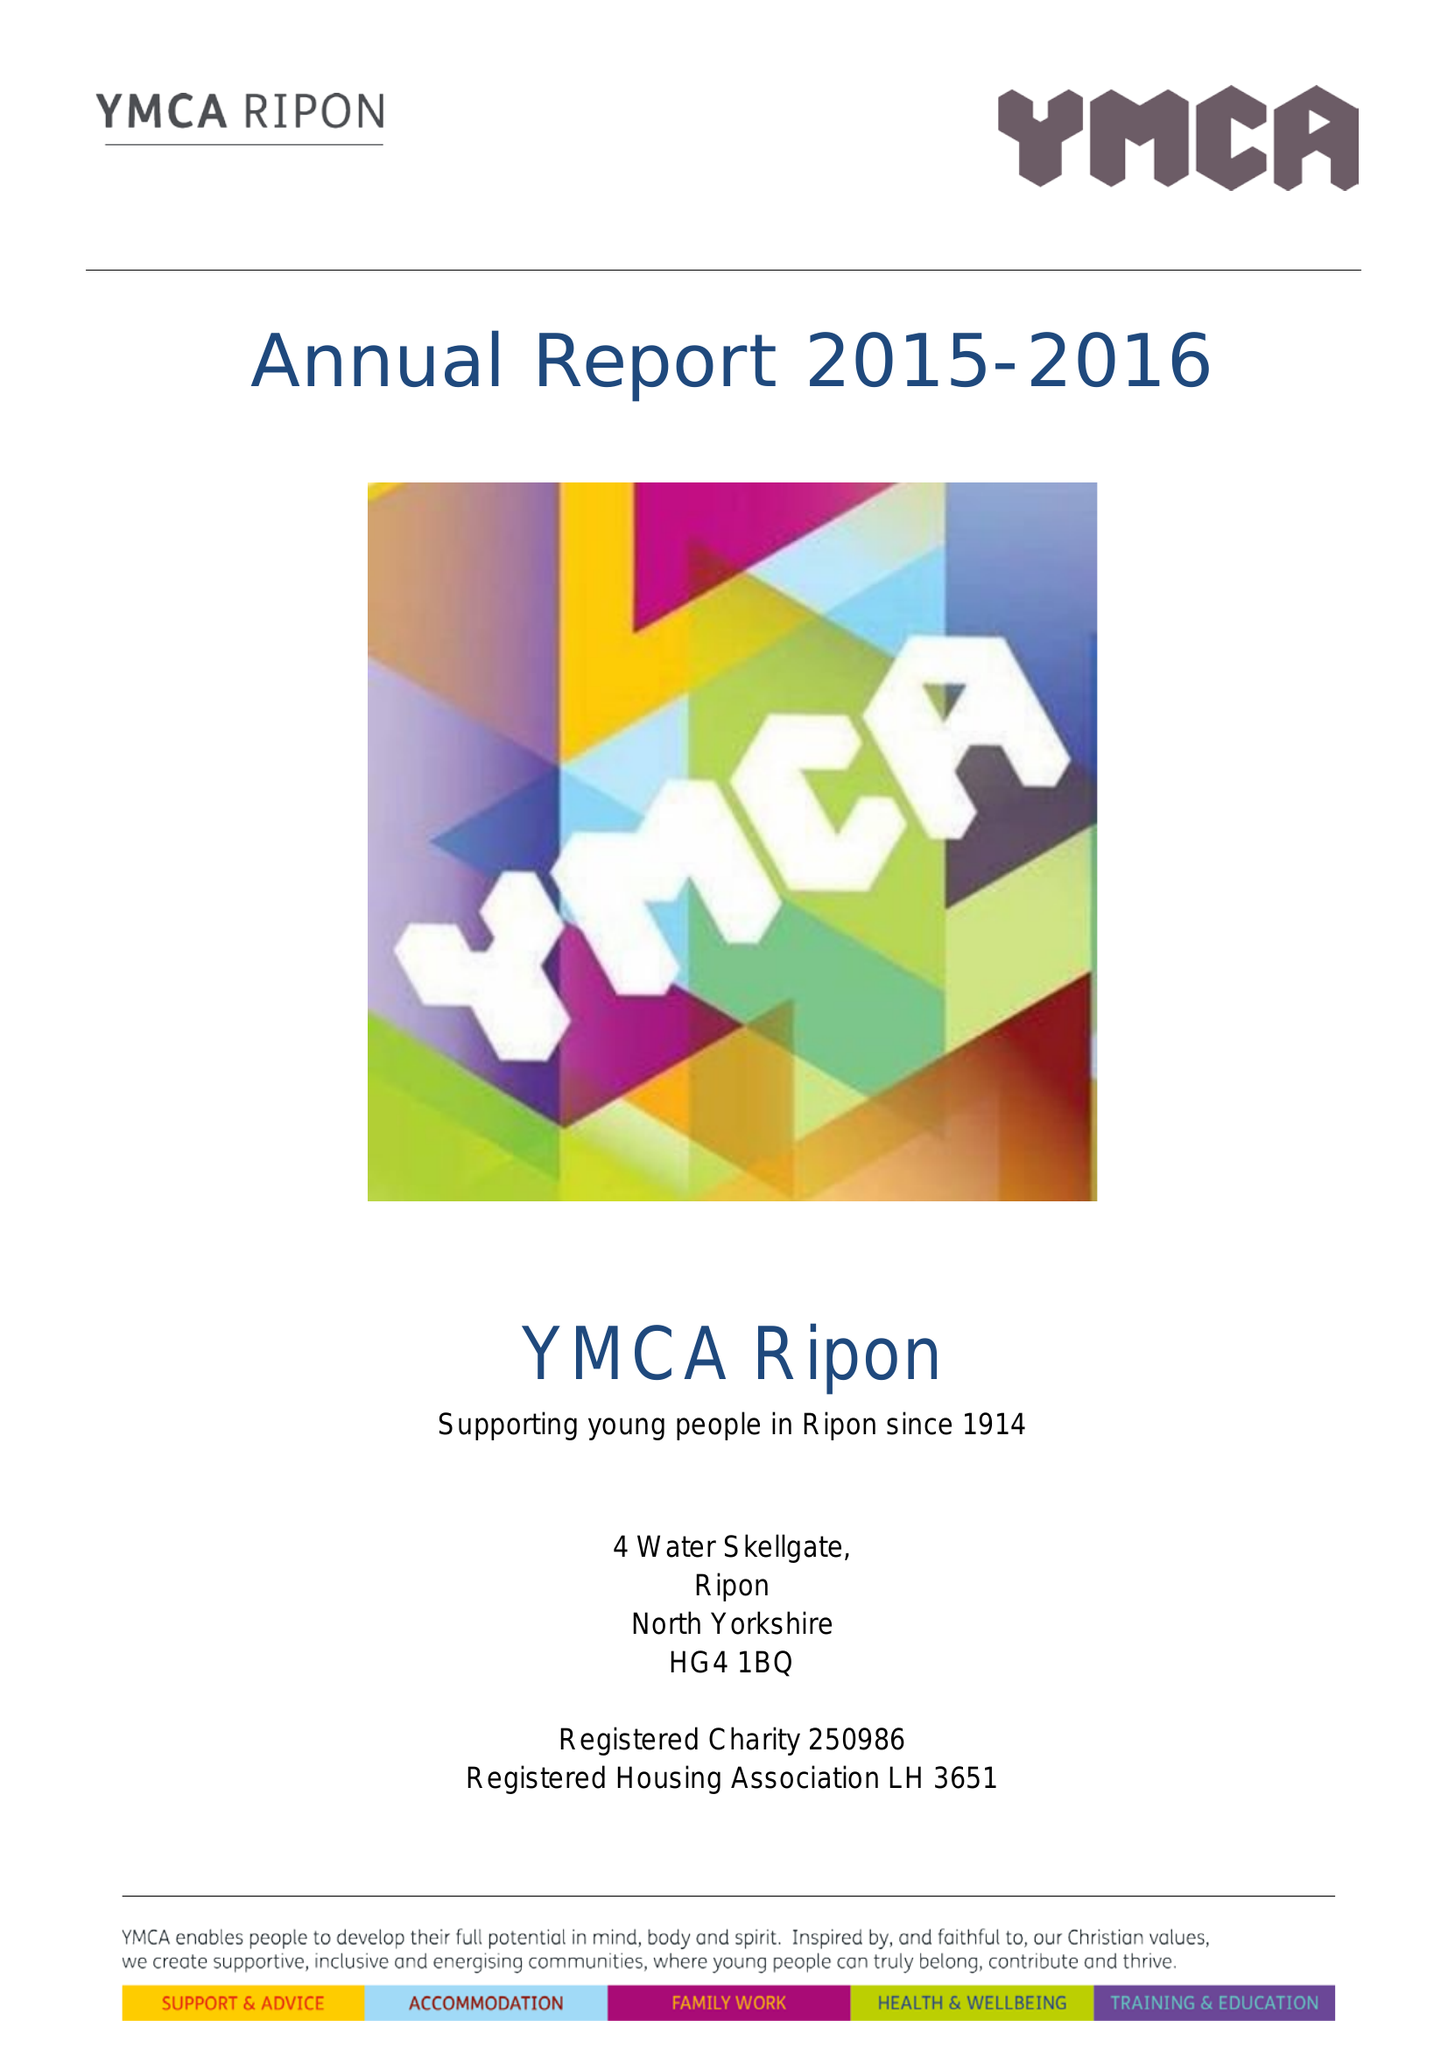What is the value for the spending_annually_in_british_pounds?
Answer the question using a single word or phrase. 146044.00 